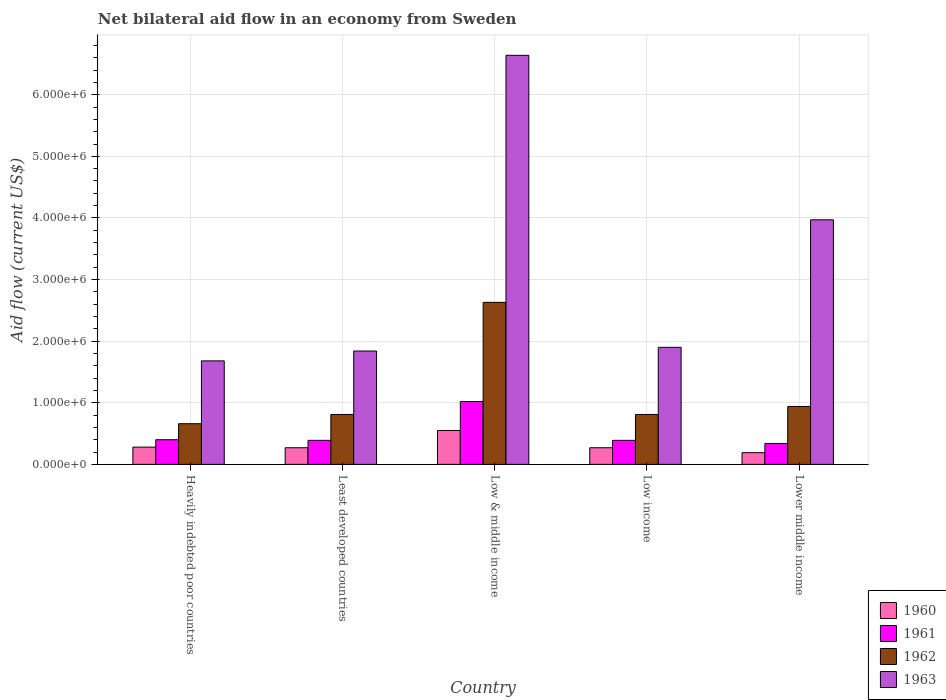How many different coloured bars are there?
Provide a short and direct response. 4. How many bars are there on the 3rd tick from the left?
Offer a very short reply. 4. What is the label of the 5th group of bars from the left?
Provide a short and direct response. Lower middle income. What is the net bilateral aid flow in 1962 in Low income?
Keep it short and to the point. 8.10e+05. Across all countries, what is the maximum net bilateral aid flow in 1960?
Your answer should be compact. 5.50e+05. In which country was the net bilateral aid flow in 1961 maximum?
Provide a short and direct response. Low & middle income. In which country was the net bilateral aid flow in 1962 minimum?
Provide a succinct answer. Heavily indebted poor countries. What is the total net bilateral aid flow in 1963 in the graph?
Keep it short and to the point. 1.60e+07. What is the difference between the net bilateral aid flow in 1961 in Least developed countries and the net bilateral aid flow in 1962 in Heavily indebted poor countries?
Your answer should be very brief. -2.70e+05. What is the average net bilateral aid flow in 1960 per country?
Your answer should be compact. 3.12e+05. In how many countries, is the net bilateral aid flow in 1963 greater than 6000000 US$?
Keep it short and to the point. 1. Is the difference between the net bilateral aid flow in 1961 in Least developed countries and Lower middle income greater than the difference between the net bilateral aid flow in 1960 in Least developed countries and Lower middle income?
Provide a succinct answer. No. What is the difference between the highest and the second highest net bilateral aid flow in 1960?
Your answer should be compact. 2.80e+05. What is the difference between the highest and the lowest net bilateral aid flow in 1962?
Provide a short and direct response. 1.97e+06. In how many countries, is the net bilateral aid flow in 1963 greater than the average net bilateral aid flow in 1963 taken over all countries?
Offer a terse response. 2. Is the sum of the net bilateral aid flow in 1962 in Heavily indebted poor countries and Low income greater than the maximum net bilateral aid flow in 1961 across all countries?
Offer a very short reply. Yes. Is it the case that in every country, the sum of the net bilateral aid flow in 1963 and net bilateral aid flow in 1962 is greater than the sum of net bilateral aid flow in 1961 and net bilateral aid flow in 1960?
Offer a terse response. Yes. How many countries are there in the graph?
Offer a very short reply. 5. How are the legend labels stacked?
Keep it short and to the point. Vertical. What is the title of the graph?
Provide a short and direct response. Net bilateral aid flow in an economy from Sweden. What is the label or title of the X-axis?
Offer a terse response. Country. What is the label or title of the Y-axis?
Your answer should be very brief. Aid flow (current US$). What is the Aid flow (current US$) in 1960 in Heavily indebted poor countries?
Make the answer very short. 2.80e+05. What is the Aid flow (current US$) of 1963 in Heavily indebted poor countries?
Offer a very short reply. 1.68e+06. What is the Aid flow (current US$) of 1961 in Least developed countries?
Your answer should be very brief. 3.90e+05. What is the Aid flow (current US$) of 1962 in Least developed countries?
Offer a terse response. 8.10e+05. What is the Aid flow (current US$) in 1963 in Least developed countries?
Give a very brief answer. 1.84e+06. What is the Aid flow (current US$) of 1960 in Low & middle income?
Provide a short and direct response. 5.50e+05. What is the Aid flow (current US$) of 1961 in Low & middle income?
Your response must be concise. 1.02e+06. What is the Aid flow (current US$) of 1962 in Low & middle income?
Your answer should be compact. 2.63e+06. What is the Aid flow (current US$) of 1963 in Low & middle income?
Ensure brevity in your answer.  6.64e+06. What is the Aid flow (current US$) in 1960 in Low income?
Your answer should be very brief. 2.70e+05. What is the Aid flow (current US$) of 1961 in Low income?
Your answer should be compact. 3.90e+05. What is the Aid flow (current US$) of 1962 in Low income?
Provide a short and direct response. 8.10e+05. What is the Aid flow (current US$) in 1963 in Low income?
Offer a very short reply. 1.90e+06. What is the Aid flow (current US$) of 1961 in Lower middle income?
Offer a very short reply. 3.40e+05. What is the Aid flow (current US$) of 1962 in Lower middle income?
Your answer should be compact. 9.40e+05. What is the Aid flow (current US$) of 1963 in Lower middle income?
Give a very brief answer. 3.97e+06. Across all countries, what is the maximum Aid flow (current US$) in 1961?
Make the answer very short. 1.02e+06. Across all countries, what is the maximum Aid flow (current US$) of 1962?
Provide a short and direct response. 2.63e+06. Across all countries, what is the maximum Aid flow (current US$) in 1963?
Your response must be concise. 6.64e+06. Across all countries, what is the minimum Aid flow (current US$) in 1961?
Keep it short and to the point. 3.40e+05. Across all countries, what is the minimum Aid flow (current US$) in 1963?
Ensure brevity in your answer.  1.68e+06. What is the total Aid flow (current US$) in 1960 in the graph?
Make the answer very short. 1.56e+06. What is the total Aid flow (current US$) of 1961 in the graph?
Make the answer very short. 2.54e+06. What is the total Aid flow (current US$) in 1962 in the graph?
Give a very brief answer. 5.85e+06. What is the total Aid flow (current US$) in 1963 in the graph?
Your answer should be very brief. 1.60e+07. What is the difference between the Aid flow (current US$) of 1961 in Heavily indebted poor countries and that in Least developed countries?
Provide a short and direct response. 10000. What is the difference between the Aid flow (current US$) of 1962 in Heavily indebted poor countries and that in Least developed countries?
Give a very brief answer. -1.50e+05. What is the difference between the Aid flow (current US$) of 1961 in Heavily indebted poor countries and that in Low & middle income?
Your answer should be compact. -6.20e+05. What is the difference between the Aid flow (current US$) in 1962 in Heavily indebted poor countries and that in Low & middle income?
Give a very brief answer. -1.97e+06. What is the difference between the Aid flow (current US$) in 1963 in Heavily indebted poor countries and that in Low & middle income?
Your answer should be compact. -4.96e+06. What is the difference between the Aid flow (current US$) of 1960 in Heavily indebted poor countries and that in Low income?
Ensure brevity in your answer.  10000. What is the difference between the Aid flow (current US$) in 1962 in Heavily indebted poor countries and that in Low income?
Offer a terse response. -1.50e+05. What is the difference between the Aid flow (current US$) in 1960 in Heavily indebted poor countries and that in Lower middle income?
Your answer should be compact. 9.00e+04. What is the difference between the Aid flow (current US$) of 1961 in Heavily indebted poor countries and that in Lower middle income?
Your answer should be compact. 6.00e+04. What is the difference between the Aid flow (current US$) of 1962 in Heavily indebted poor countries and that in Lower middle income?
Offer a terse response. -2.80e+05. What is the difference between the Aid flow (current US$) of 1963 in Heavily indebted poor countries and that in Lower middle income?
Your answer should be very brief. -2.29e+06. What is the difference between the Aid flow (current US$) in 1960 in Least developed countries and that in Low & middle income?
Give a very brief answer. -2.80e+05. What is the difference between the Aid flow (current US$) in 1961 in Least developed countries and that in Low & middle income?
Make the answer very short. -6.30e+05. What is the difference between the Aid flow (current US$) of 1962 in Least developed countries and that in Low & middle income?
Give a very brief answer. -1.82e+06. What is the difference between the Aid flow (current US$) of 1963 in Least developed countries and that in Low & middle income?
Your answer should be compact. -4.80e+06. What is the difference between the Aid flow (current US$) of 1960 in Least developed countries and that in Low income?
Your answer should be compact. 0. What is the difference between the Aid flow (current US$) of 1963 in Least developed countries and that in Lower middle income?
Provide a short and direct response. -2.13e+06. What is the difference between the Aid flow (current US$) in 1960 in Low & middle income and that in Low income?
Your response must be concise. 2.80e+05. What is the difference between the Aid flow (current US$) of 1961 in Low & middle income and that in Low income?
Give a very brief answer. 6.30e+05. What is the difference between the Aid flow (current US$) of 1962 in Low & middle income and that in Low income?
Offer a terse response. 1.82e+06. What is the difference between the Aid flow (current US$) in 1963 in Low & middle income and that in Low income?
Your response must be concise. 4.74e+06. What is the difference between the Aid flow (current US$) in 1960 in Low & middle income and that in Lower middle income?
Your answer should be very brief. 3.60e+05. What is the difference between the Aid flow (current US$) of 1961 in Low & middle income and that in Lower middle income?
Ensure brevity in your answer.  6.80e+05. What is the difference between the Aid flow (current US$) in 1962 in Low & middle income and that in Lower middle income?
Offer a terse response. 1.69e+06. What is the difference between the Aid flow (current US$) of 1963 in Low & middle income and that in Lower middle income?
Keep it short and to the point. 2.67e+06. What is the difference between the Aid flow (current US$) of 1962 in Low income and that in Lower middle income?
Ensure brevity in your answer.  -1.30e+05. What is the difference between the Aid flow (current US$) in 1963 in Low income and that in Lower middle income?
Your answer should be compact. -2.07e+06. What is the difference between the Aid flow (current US$) in 1960 in Heavily indebted poor countries and the Aid flow (current US$) in 1961 in Least developed countries?
Your response must be concise. -1.10e+05. What is the difference between the Aid flow (current US$) in 1960 in Heavily indebted poor countries and the Aid flow (current US$) in 1962 in Least developed countries?
Make the answer very short. -5.30e+05. What is the difference between the Aid flow (current US$) in 1960 in Heavily indebted poor countries and the Aid flow (current US$) in 1963 in Least developed countries?
Make the answer very short. -1.56e+06. What is the difference between the Aid flow (current US$) in 1961 in Heavily indebted poor countries and the Aid flow (current US$) in 1962 in Least developed countries?
Your answer should be compact. -4.10e+05. What is the difference between the Aid flow (current US$) of 1961 in Heavily indebted poor countries and the Aid flow (current US$) of 1963 in Least developed countries?
Offer a terse response. -1.44e+06. What is the difference between the Aid flow (current US$) of 1962 in Heavily indebted poor countries and the Aid flow (current US$) of 1963 in Least developed countries?
Keep it short and to the point. -1.18e+06. What is the difference between the Aid flow (current US$) in 1960 in Heavily indebted poor countries and the Aid flow (current US$) in 1961 in Low & middle income?
Ensure brevity in your answer.  -7.40e+05. What is the difference between the Aid flow (current US$) in 1960 in Heavily indebted poor countries and the Aid flow (current US$) in 1962 in Low & middle income?
Provide a short and direct response. -2.35e+06. What is the difference between the Aid flow (current US$) of 1960 in Heavily indebted poor countries and the Aid flow (current US$) of 1963 in Low & middle income?
Your answer should be compact. -6.36e+06. What is the difference between the Aid flow (current US$) of 1961 in Heavily indebted poor countries and the Aid flow (current US$) of 1962 in Low & middle income?
Provide a short and direct response. -2.23e+06. What is the difference between the Aid flow (current US$) in 1961 in Heavily indebted poor countries and the Aid flow (current US$) in 1963 in Low & middle income?
Offer a very short reply. -6.24e+06. What is the difference between the Aid flow (current US$) of 1962 in Heavily indebted poor countries and the Aid flow (current US$) of 1963 in Low & middle income?
Your answer should be compact. -5.98e+06. What is the difference between the Aid flow (current US$) of 1960 in Heavily indebted poor countries and the Aid flow (current US$) of 1962 in Low income?
Ensure brevity in your answer.  -5.30e+05. What is the difference between the Aid flow (current US$) of 1960 in Heavily indebted poor countries and the Aid flow (current US$) of 1963 in Low income?
Your answer should be compact. -1.62e+06. What is the difference between the Aid flow (current US$) of 1961 in Heavily indebted poor countries and the Aid flow (current US$) of 1962 in Low income?
Make the answer very short. -4.10e+05. What is the difference between the Aid flow (current US$) in 1961 in Heavily indebted poor countries and the Aid flow (current US$) in 1963 in Low income?
Provide a succinct answer. -1.50e+06. What is the difference between the Aid flow (current US$) of 1962 in Heavily indebted poor countries and the Aid flow (current US$) of 1963 in Low income?
Provide a succinct answer. -1.24e+06. What is the difference between the Aid flow (current US$) in 1960 in Heavily indebted poor countries and the Aid flow (current US$) in 1962 in Lower middle income?
Ensure brevity in your answer.  -6.60e+05. What is the difference between the Aid flow (current US$) in 1960 in Heavily indebted poor countries and the Aid flow (current US$) in 1963 in Lower middle income?
Your answer should be compact. -3.69e+06. What is the difference between the Aid flow (current US$) of 1961 in Heavily indebted poor countries and the Aid flow (current US$) of 1962 in Lower middle income?
Your answer should be very brief. -5.40e+05. What is the difference between the Aid flow (current US$) of 1961 in Heavily indebted poor countries and the Aid flow (current US$) of 1963 in Lower middle income?
Provide a short and direct response. -3.57e+06. What is the difference between the Aid flow (current US$) of 1962 in Heavily indebted poor countries and the Aid flow (current US$) of 1963 in Lower middle income?
Provide a succinct answer. -3.31e+06. What is the difference between the Aid flow (current US$) in 1960 in Least developed countries and the Aid flow (current US$) in 1961 in Low & middle income?
Provide a succinct answer. -7.50e+05. What is the difference between the Aid flow (current US$) in 1960 in Least developed countries and the Aid flow (current US$) in 1962 in Low & middle income?
Your answer should be very brief. -2.36e+06. What is the difference between the Aid flow (current US$) of 1960 in Least developed countries and the Aid flow (current US$) of 1963 in Low & middle income?
Offer a terse response. -6.37e+06. What is the difference between the Aid flow (current US$) of 1961 in Least developed countries and the Aid flow (current US$) of 1962 in Low & middle income?
Your response must be concise. -2.24e+06. What is the difference between the Aid flow (current US$) in 1961 in Least developed countries and the Aid flow (current US$) in 1963 in Low & middle income?
Provide a succinct answer. -6.25e+06. What is the difference between the Aid flow (current US$) in 1962 in Least developed countries and the Aid flow (current US$) in 1963 in Low & middle income?
Provide a succinct answer. -5.83e+06. What is the difference between the Aid flow (current US$) in 1960 in Least developed countries and the Aid flow (current US$) in 1961 in Low income?
Ensure brevity in your answer.  -1.20e+05. What is the difference between the Aid flow (current US$) of 1960 in Least developed countries and the Aid flow (current US$) of 1962 in Low income?
Offer a very short reply. -5.40e+05. What is the difference between the Aid flow (current US$) of 1960 in Least developed countries and the Aid flow (current US$) of 1963 in Low income?
Offer a very short reply. -1.63e+06. What is the difference between the Aid flow (current US$) of 1961 in Least developed countries and the Aid flow (current US$) of 1962 in Low income?
Your answer should be very brief. -4.20e+05. What is the difference between the Aid flow (current US$) in 1961 in Least developed countries and the Aid flow (current US$) in 1963 in Low income?
Your answer should be compact. -1.51e+06. What is the difference between the Aid flow (current US$) in 1962 in Least developed countries and the Aid flow (current US$) in 1963 in Low income?
Give a very brief answer. -1.09e+06. What is the difference between the Aid flow (current US$) of 1960 in Least developed countries and the Aid flow (current US$) of 1961 in Lower middle income?
Ensure brevity in your answer.  -7.00e+04. What is the difference between the Aid flow (current US$) in 1960 in Least developed countries and the Aid flow (current US$) in 1962 in Lower middle income?
Your response must be concise. -6.70e+05. What is the difference between the Aid flow (current US$) of 1960 in Least developed countries and the Aid flow (current US$) of 1963 in Lower middle income?
Ensure brevity in your answer.  -3.70e+06. What is the difference between the Aid flow (current US$) of 1961 in Least developed countries and the Aid flow (current US$) of 1962 in Lower middle income?
Offer a very short reply. -5.50e+05. What is the difference between the Aid flow (current US$) in 1961 in Least developed countries and the Aid flow (current US$) in 1963 in Lower middle income?
Ensure brevity in your answer.  -3.58e+06. What is the difference between the Aid flow (current US$) of 1962 in Least developed countries and the Aid flow (current US$) of 1963 in Lower middle income?
Your answer should be very brief. -3.16e+06. What is the difference between the Aid flow (current US$) of 1960 in Low & middle income and the Aid flow (current US$) of 1962 in Low income?
Provide a short and direct response. -2.60e+05. What is the difference between the Aid flow (current US$) of 1960 in Low & middle income and the Aid flow (current US$) of 1963 in Low income?
Your response must be concise. -1.35e+06. What is the difference between the Aid flow (current US$) of 1961 in Low & middle income and the Aid flow (current US$) of 1962 in Low income?
Your answer should be compact. 2.10e+05. What is the difference between the Aid flow (current US$) of 1961 in Low & middle income and the Aid flow (current US$) of 1963 in Low income?
Your response must be concise. -8.80e+05. What is the difference between the Aid flow (current US$) of 1962 in Low & middle income and the Aid flow (current US$) of 1963 in Low income?
Your answer should be very brief. 7.30e+05. What is the difference between the Aid flow (current US$) in 1960 in Low & middle income and the Aid flow (current US$) in 1962 in Lower middle income?
Your answer should be compact. -3.90e+05. What is the difference between the Aid flow (current US$) of 1960 in Low & middle income and the Aid flow (current US$) of 1963 in Lower middle income?
Provide a short and direct response. -3.42e+06. What is the difference between the Aid flow (current US$) of 1961 in Low & middle income and the Aid flow (current US$) of 1963 in Lower middle income?
Keep it short and to the point. -2.95e+06. What is the difference between the Aid flow (current US$) in 1962 in Low & middle income and the Aid flow (current US$) in 1963 in Lower middle income?
Offer a terse response. -1.34e+06. What is the difference between the Aid flow (current US$) in 1960 in Low income and the Aid flow (current US$) in 1962 in Lower middle income?
Your answer should be very brief. -6.70e+05. What is the difference between the Aid flow (current US$) of 1960 in Low income and the Aid flow (current US$) of 1963 in Lower middle income?
Give a very brief answer. -3.70e+06. What is the difference between the Aid flow (current US$) in 1961 in Low income and the Aid flow (current US$) in 1962 in Lower middle income?
Provide a short and direct response. -5.50e+05. What is the difference between the Aid flow (current US$) of 1961 in Low income and the Aid flow (current US$) of 1963 in Lower middle income?
Make the answer very short. -3.58e+06. What is the difference between the Aid flow (current US$) in 1962 in Low income and the Aid flow (current US$) in 1963 in Lower middle income?
Ensure brevity in your answer.  -3.16e+06. What is the average Aid flow (current US$) in 1960 per country?
Offer a terse response. 3.12e+05. What is the average Aid flow (current US$) of 1961 per country?
Offer a terse response. 5.08e+05. What is the average Aid flow (current US$) in 1962 per country?
Offer a terse response. 1.17e+06. What is the average Aid flow (current US$) of 1963 per country?
Give a very brief answer. 3.21e+06. What is the difference between the Aid flow (current US$) in 1960 and Aid flow (current US$) in 1961 in Heavily indebted poor countries?
Give a very brief answer. -1.20e+05. What is the difference between the Aid flow (current US$) in 1960 and Aid flow (current US$) in 1962 in Heavily indebted poor countries?
Give a very brief answer. -3.80e+05. What is the difference between the Aid flow (current US$) in 1960 and Aid flow (current US$) in 1963 in Heavily indebted poor countries?
Keep it short and to the point. -1.40e+06. What is the difference between the Aid flow (current US$) in 1961 and Aid flow (current US$) in 1962 in Heavily indebted poor countries?
Your answer should be very brief. -2.60e+05. What is the difference between the Aid flow (current US$) of 1961 and Aid flow (current US$) of 1963 in Heavily indebted poor countries?
Keep it short and to the point. -1.28e+06. What is the difference between the Aid flow (current US$) of 1962 and Aid flow (current US$) of 1963 in Heavily indebted poor countries?
Your answer should be compact. -1.02e+06. What is the difference between the Aid flow (current US$) in 1960 and Aid flow (current US$) in 1962 in Least developed countries?
Your answer should be compact. -5.40e+05. What is the difference between the Aid flow (current US$) in 1960 and Aid flow (current US$) in 1963 in Least developed countries?
Ensure brevity in your answer.  -1.57e+06. What is the difference between the Aid flow (current US$) in 1961 and Aid flow (current US$) in 1962 in Least developed countries?
Ensure brevity in your answer.  -4.20e+05. What is the difference between the Aid flow (current US$) in 1961 and Aid flow (current US$) in 1963 in Least developed countries?
Give a very brief answer. -1.45e+06. What is the difference between the Aid flow (current US$) in 1962 and Aid flow (current US$) in 1963 in Least developed countries?
Your answer should be compact. -1.03e+06. What is the difference between the Aid flow (current US$) of 1960 and Aid flow (current US$) of 1961 in Low & middle income?
Offer a terse response. -4.70e+05. What is the difference between the Aid flow (current US$) in 1960 and Aid flow (current US$) in 1962 in Low & middle income?
Ensure brevity in your answer.  -2.08e+06. What is the difference between the Aid flow (current US$) in 1960 and Aid flow (current US$) in 1963 in Low & middle income?
Your answer should be compact. -6.09e+06. What is the difference between the Aid flow (current US$) in 1961 and Aid flow (current US$) in 1962 in Low & middle income?
Give a very brief answer. -1.61e+06. What is the difference between the Aid flow (current US$) in 1961 and Aid flow (current US$) in 1963 in Low & middle income?
Your answer should be compact. -5.62e+06. What is the difference between the Aid flow (current US$) of 1962 and Aid flow (current US$) of 1963 in Low & middle income?
Give a very brief answer. -4.01e+06. What is the difference between the Aid flow (current US$) of 1960 and Aid flow (current US$) of 1962 in Low income?
Offer a terse response. -5.40e+05. What is the difference between the Aid flow (current US$) in 1960 and Aid flow (current US$) in 1963 in Low income?
Give a very brief answer. -1.63e+06. What is the difference between the Aid flow (current US$) of 1961 and Aid flow (current US$) of 1962 in Low income?
Make the answer very short. -4.20e+05. What is the difference between the Aid flow (current US$) of 1961 and Aid flow (current US$) of 1963 in Low income?
Your answer should be compact. -1.51e+06. What is the difference between the Aid flow (current US$) of 1962 and Aid flow (current US$) of 1963 in Low income?
Offer a very short reply. -1.09e+06. What is the difference between the Aid flow (current US$) in 1960 and Aid flow (current US$) in 1962 in Lower middle income?
Ensure brevity in your answer.  -7.50e+05. What is the difference between the Aid flow (current US$) of 1960 and Aid flow (current US$) of 1963 in Lower middle income?
Ensure brevity in your answer.  -3.78e+06. What is the difference between the Aid flow (current US$) of 1961 and Aid flow (current US$) of 1962 in Lower middle income?
Your answer should be very brief. -6.00e+05. What is the difference between the Aid flow (current US$) of 1961 and Aid flow (current US$) of 1963 in Lower middle income?
Offer a very short reply. -3.63e+06. What is the difference between the Aid flow (current US$) of 1962 and Aid flow (current US$) of 1963 in Lower middle income?
Ensure brevity in your answer.  -3.03e+06. What is the ratio of the Aid flow (current US$) in 1961 in Heavily indebted poor countries to that in Least developed countries?
Offer a terse response. 1.03. What is the ratio of the Aid flow (current US$) in 1962 in Heavily indebted poor countries to that in Least developed countries?
Provide a short and direct response. 0.81. What is the ratio of the Aid flow (current US$) of 1960 in Heavily indebted poor countries to that in Low & middle income?
Ensure brevity in your answer.  0.51. What is the ratio of the Aid flow (current US$) in 1961 in Heavily indebted poor countries to that in Low & middle income?
Keep it short and to the point. 0.39. What is the ratio of the Aid flow (current US$) of 1962 in Heavily indebted poor countries to that in Low & middle income?
Ensure brevity in your answer.  0.25. What is the ratio of the Aid flow (current US$) in 1963 in Heavily indebted poor countries to that in Low & middle income?
Provide a succinct answer. 0.25. What is the ratio of the Aid flow (current US$) of 1960 in Heavily indebted poor countries to that in Low income?
Offer a terse response. 1.04. What is the ratio of the Aid flow (current US$) in 1961 in Heavily indebted poor countries to that in Low income?
Provide a short and direct response. 1.03. What is the ratio of the Aid flow (current US$) in 1962 in Heavily indebted poor countries to that in Low income?
Keep it short and to the point. 0.81. What is the ratio of the Aid flow (current US$) in 1963 in Heavily indebted poor countries to that in Low income?
Your answer should be very brief. 0.88. What is the ratio of the Aid flow (current US$) in 1960 in Heavily indebted poor countries to that in Lower middle income?
Provide a short and direct response. 1.47. What is the ratio of the Aid flow (current US$) in 1961 in Heavily indebted poor countries to that in Lower middle income?
Provide a short and direct response. 1.18. What is the ratio of the Aid flow (current US$) in 1962 in Heavily indebted poor countries to that in Lower middle income?
Provide a short and direct response. 0.7. What is the ratio of the Aid flow (current US$) of 1963 in Heavily indebted poor countries to that in Lower middle income?
Provide a succinct answer. 0.42. What is the ratio of the Aid flow (current US$) in 1960 in Least developed countries to that in Low & middle income?
Offer a terse response. 0.49. What is the ratio of the Aid flow (current US$) of 1961 in Least developed countries to that in Low & middle income?
Provide a succinct answer. 0.38. What is the ratio of the Aid flow (current US$) of 1962 in Least developed countries to that in Low & middle income?
Offer a very short reply. 0.31. What is the ratio of the Aid flow (current US$) in 1963 in Least developed countries to that in Low & middle income?
Give a very brief answer. 0.28. What is the ratio of the Aid flow (current US$) in 1960 in Least developed countries to that in Low income?
Your answer should be very brief. 1. What is the ratio of the Aid flow (current US$) of 1961 in Least developed countries to that in Low income?
Give a very brief answer. 1. What is the ratio of the Aid flow (current US$) in 1962 in Least developed countries to that in Low income?
Provide a succinct answer. 1. What is the ratio of the Aid flow (current US$) in 1963 in Least developed countries to that in Low income?
Offer a terse response. 0.97. What is the ratio of the Aid flow (current US$) in 1960 in Least developed countries to that in Lower middle income?
Offer a very short reply. 1.42. What is the ratio of the Aid flow (current US$) of 1961 in Least developed countries to that in Lower middle income?
Provide a succinct answer. 1.15. What is the ratio of the Aid flow (current US$) in 1962 in Least developed countries to that in Lower middle income?
Offer a terse response. 0.86. What is the ratio of the Aid flow (current US$) of 1963 in Least developed countries to that in Lower middle income?
Offer a very short reply. 0.46. What is the ratio of the Aid flow (current US$) in 1960 in Low & middle income to that in Low income?
Your response must be concise. 2.04. What is the ratio of the Aid flow (current US$) in 1961 in Low & middle income to that in Low income?
Ensure brevity in your answer.  2.62. What is the ratio of the Aid flow (current US$) in 1962 in Low & middle income to that in Low income?
Ensure brevity in your answer.  3.25. What is the ratio of the Aid flow (current US$) in 1963 in Low & middle income to that in Low income?
Your answer should be very brief. 3.49. What is the ratio of the Aid flow (current US$) of 1960 in Low & middle income to that in Lower middle income?
Give a very brief answer. 2.89. What is the ratio of the Aid flow (current US$) of 1961 in Low & middle income to that in Lower middle income?
Provide a succinct answer. 3. What is the ratio of the Aid flow (current US$) of 1962 in Low & middle income to that in Lower middle income?
Offer a terse response. 2.8. What is the ratio of the Aid flow (current US$) in 1963 in Low & middle income to that in Lower middle income?
Ensure brevity in your answer.  1.67. What is the ratio of the Aid flow (current US$) in 1960 in Low income to that in Lower middle income?
Make the answer very short. 1.42. What is the ratio of the Aid flow (current US$) of 1961 in Low income to that in Lower middle income?
Your answer should be very brief. 1.15. What is the ratio of the Aid flow (current US$) of 1962 in Low income to that in Lower middle income?
Offer a very short reply. 0.86. What is the ratio of the Aid flow (current US$) of 1963 in Low income to that in Lower middle income?
Provide a short and direct response. 0.48. What is the difference between the highest and the second highest Aid flow (current US$) in 1961?
Provide a succinct answer. 6.20e+05. What is the difference between the highest and the second highest Aid flow (current US$) of 1962?
Keep it short and to the point. 1.69e+06. What is the difference between the highest and the second highest Aid flow (current US$) of 1963?
Provide a short and direct response. 2.67e+06. What is the difference between the highest and the lowest Aid flow (current US$) of 1960?
Make the answer very short. 3.60e+05. What is the difference between the highest and the lowest Aid flow (current US$) of 1961?
Your response must be concise. 6.80e+05. What is the difference between the highest and the lowest Aid flow (current US$) in 1962?
Make the answer very short. 1.97e+06. What is the difference between the highest and the lowest Aid flow (current US$) of 1963?
Your answer should be very brief. 4.96e+06. 